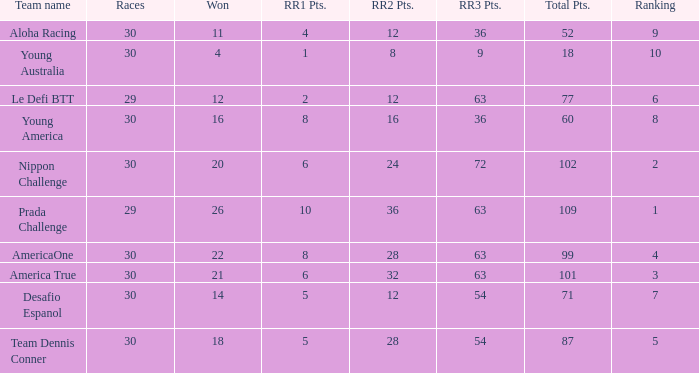Name the total number of rr2 pts for won being 11 1.0. 